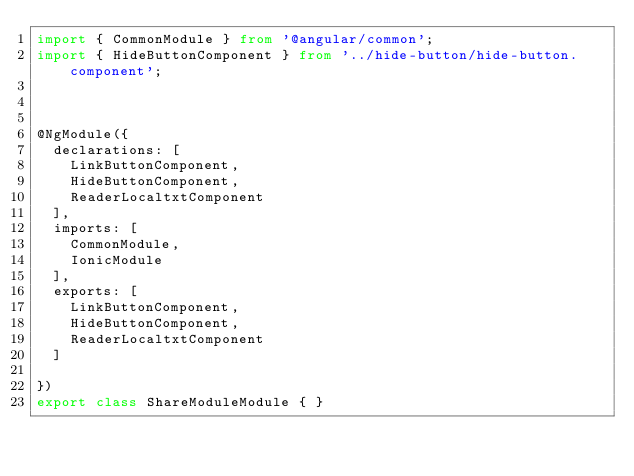Convert code to text. <code><loc_0><loc_0><loc_500><loc_500><_TypeScript_>import { CommonModule } from '@angular/common';
import { HideButtonComponent } from '../hide-button/hide-button.component';



@NgModule({
  declarations: [
    LinkButtonComponent,
    HideButtonComponent,
    ReaderLocaltxtComponent
  ],
  imports: [
    CommonModule,
    IonicModule
  ],
  exports: [
    LinkButtonComponent,
    HideButtonComponent,
    ReaderLocaltxtComponent
  ]

})
export class ShareModuleModule { }
</code> 